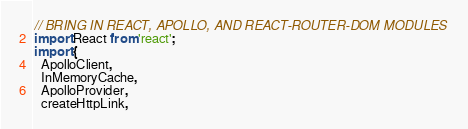Convert code to text. <code><loc_0><loc_0><loc_500><loc_500><_JavaScript_>// BRING IN REACT, APOLLO, AND REACT-ROUTER-DOM MODULES
import React from 'react';
import {
  ApolloClient,
  InMemoryCache,
  ApolloProvider,
  createHttpLink,</code> 